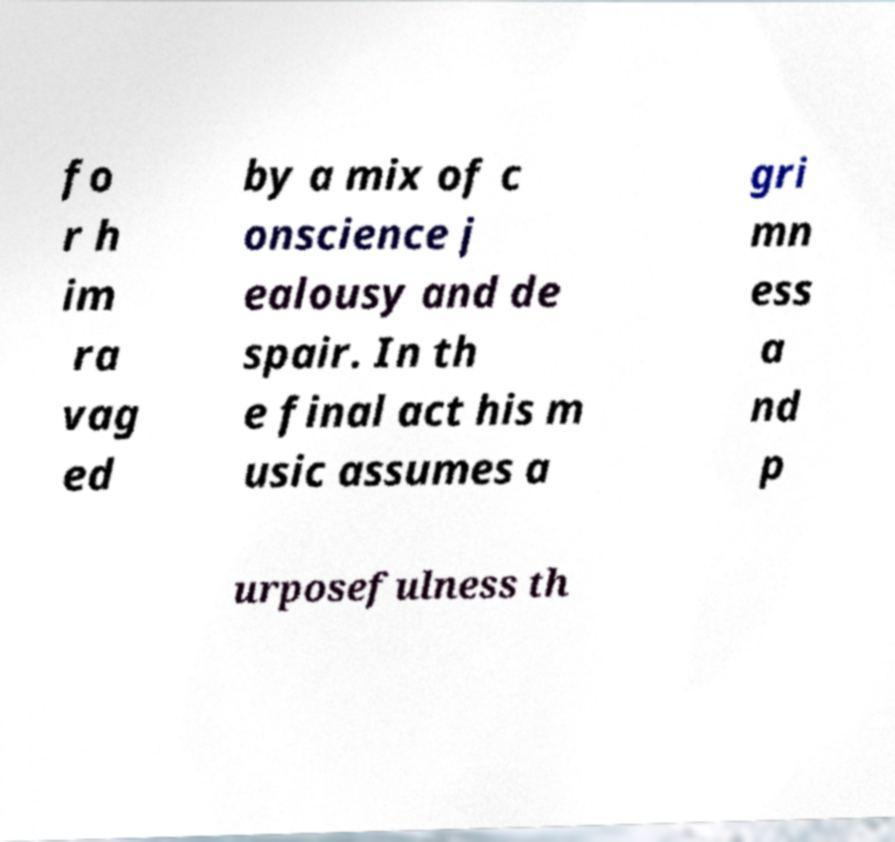Please identify and transcribe the text found in this image. fo r h im ra vag ed by a mix of c onscience j ealousy and de spair. In th e final act his m usic assumes a gri mn ess a nd p urposefulness th 